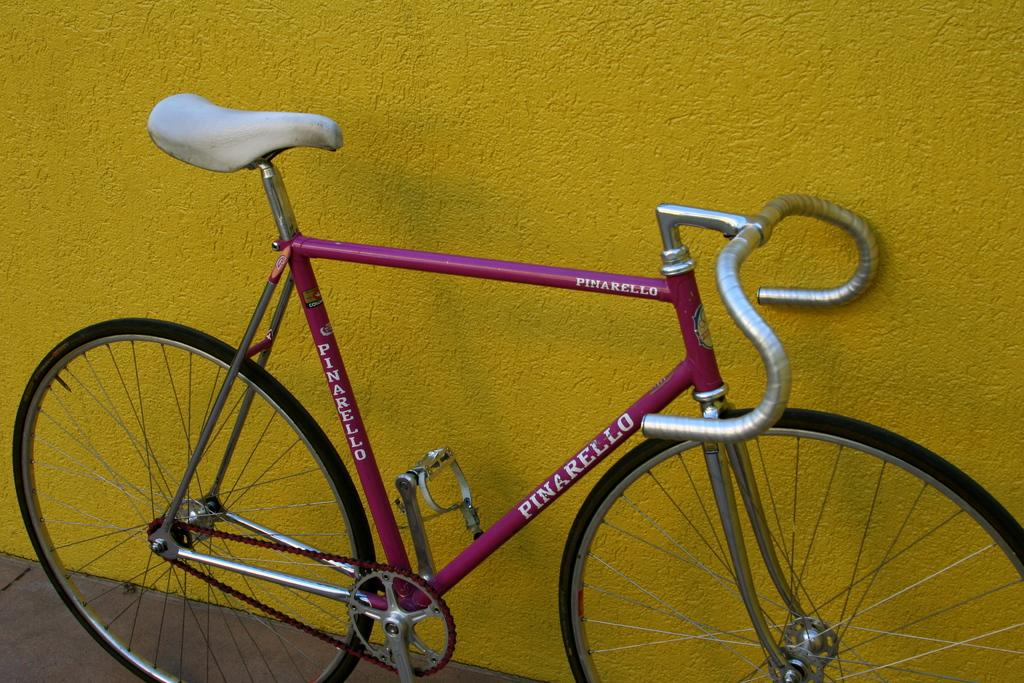What is the main object in the image? There is a bicycle in the image. Can you describe the position of the bicycle? The bicycle is on the floor. What color is the wall visible in the background of the image? There is a yellow wall in the background of the image. Can you tell me how many ears are visible on the bicycle in the image? There are no ears present on the bicycle in the image, as ears are a characteristic of living beings and not inanimate objects like bicycles. Is there a park visible in the image? There is no park visible in the image; it only features a bicycle on the floor and a yellow wall in the background. 